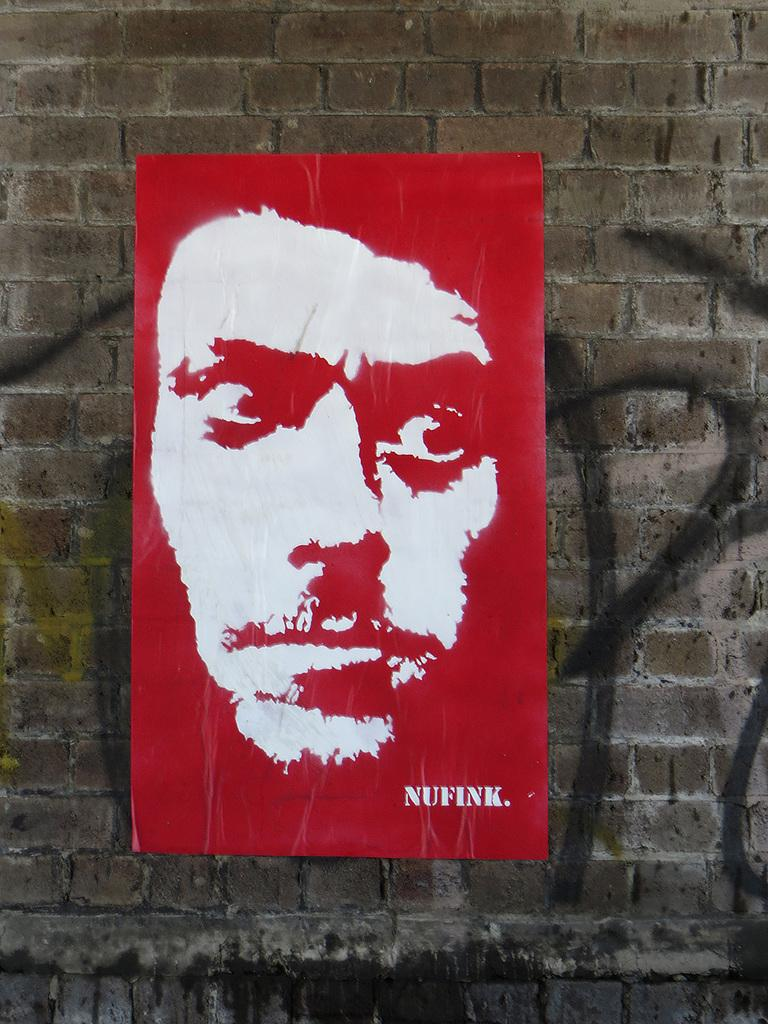<image>
Relay a brief, clear account of the picture shown. Poster against a brick wall showing NUFINK in white lettering. 